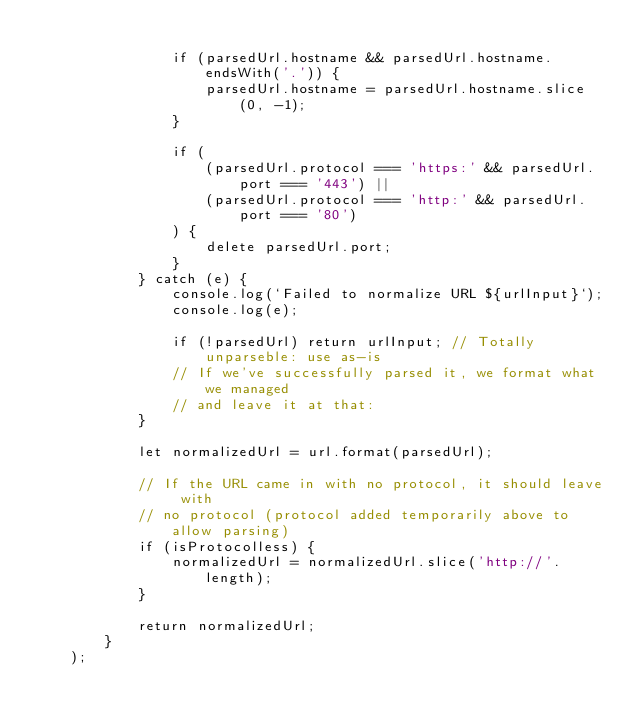Convert code to text. <code><loc_0><loc_0><loc_500><loc_500><_TypeScript_>
                if (parsedUrl.hostname && parsedUrl.hostname.endsWith('.')) {
                    parsedUrl.hostname = parsedUrl.hostname.slice(0, -1);
                }

                if (
                    (parsedUrl.protocol === 'https:' && parsedUrl.port === '443') ||
                    (parsedUrl.protocol === 'http:' && parsedUrl.port === '80')
                ) {
                    delete parsedUrl.port;
                }
            } catch (e) {
                console.log(`Failed to normalize URL ${urlInput}`);
                console.log(e);

                if (!parsedUrl) return urlInput; // Totally unparseble: use as-is
                // If we've successfully parsed it, we format what we managed
                // and leave it at that:
            }

            let normalizedUrl = url.format(parsedUrl);

            // If the URL came in with no protocol, it should leave with
            // no protocol (protocol added temporarily above to allow parsing)
            if (isProtocolless) {
                normalizedUrl = normalizedUrl.slice('http://'.length);
            }

            return normalizedUrl;
        }
    );
</code> 